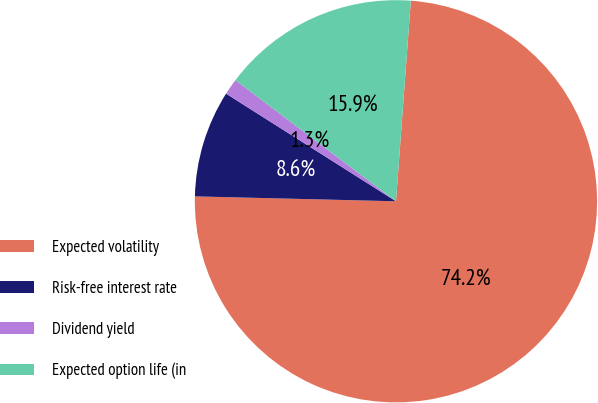<chart> <loc_0><loc_0><loc_500><loc_500><pie_chart><fcel>Expected volatility<fcel>Risk-free interest rate<fcel>Dividend yield<fcel>Expected option life (in<nl><fcel>74.21%<fcel>8.6%<fcel>1.3%<fcel>15.89%<nl></chart> 